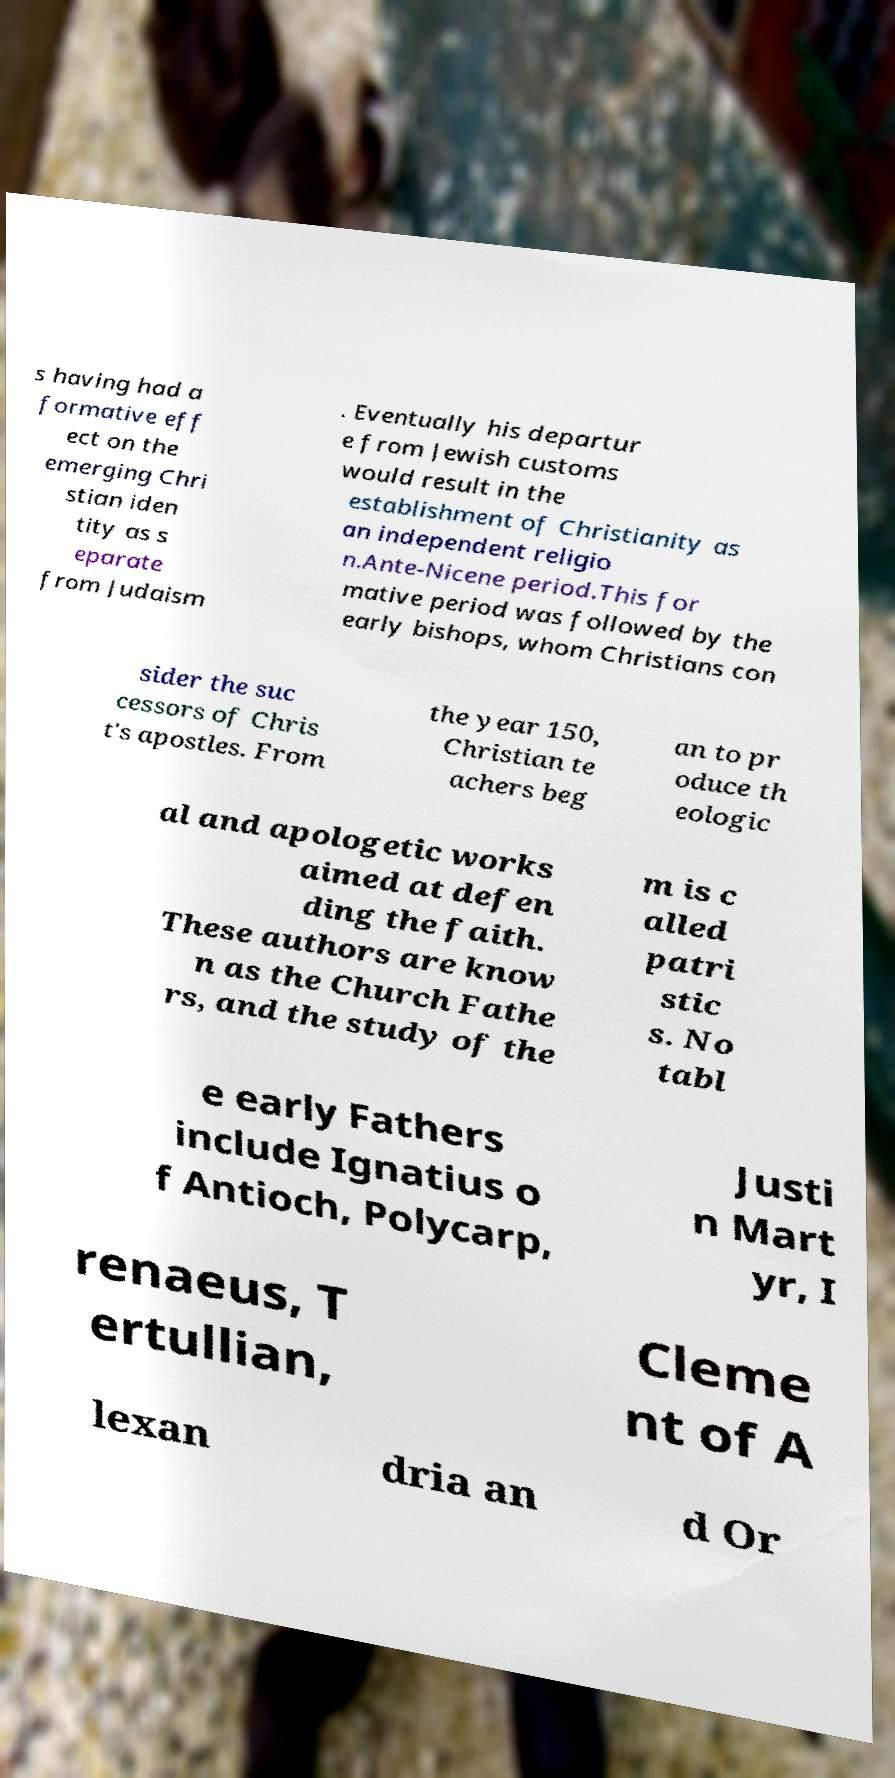Could you extract and type out the text from this image? s having had a formative eff ect on the emerging Chri stian iden tity as s eparate from Judaism . Eventually his departur e from Jewish customs would result in the establishment of Christianity as an independent religio n.Ante-Nicene period.This for mative period was followed by the early bishops, whom Christians con sider the suc cessors of Chris t's apostles. From the year 150, Christian te achers beg an to pr oduce th eologic al and apologetic works aimed at defen ding the faith. These authors are know n as the Church Fathe rs, and the study of the m is c alled patri stic s. No tabl e early Fathers include Ignatius o f Antioch, Polycarp, Justi n Mart yr, I renaeus, T ertullian, Cleme nt of A lexan dria an d Or 